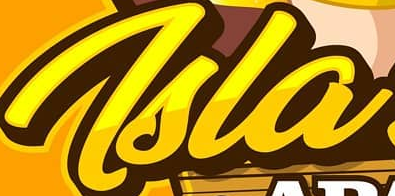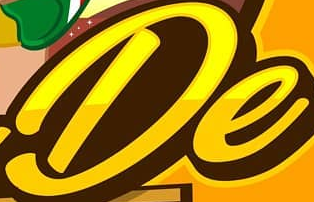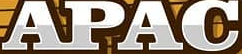What words are shown in these images in order, separated by a semicolon? Tsla; De; APAC 